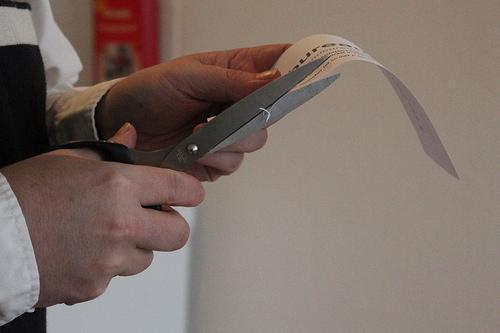How many people in the photo?
Give a very brief answer. 1. 